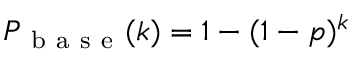Convert formula to latex. <formula><loc_0><loc_0><loc_500><loc_500>P _ { b a s e } ( k ) = 1 - ( 1 - p ) ^ { k }</formula> 